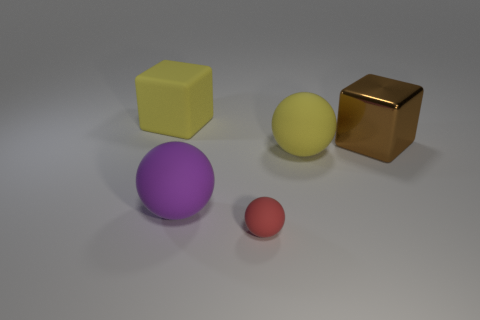Is there any other thing that has the same size as the red object?
Your answer should be compact. No. There is a large yellow thing in front of the big brown shiny block; what is it made of?
Give a very brief answer. Rubber. The red thing has what size?
Make the answer very short. Small. There is a thing behind the big shiny cube; is its size the same as the yellow matte object that is in front of the big shiny object?
Make the answer very short. Yes. There is a yellow thing that is the same shape as the small red matte thing; what size is it?
Provide a succinct answer. Large. There is a yellow block; does it have the same size as the cube that is right of the large yellow sphere?
Your answer should be very brief. Yes. There is a large yellow thing that is right of the small red rubber ball; is there a matte cube to the right of it?
Your answer should be very brief. No. What is the shape of the yellow matte object that is right of the purple rubber thing?
Keep it short and to the point. Sphere. What material is the thing that is the same color as the big rubber cube?
Offer a very short reply. Rubber. What is the color of the cube on the left side of the big sphere to the left of the tiny sphere?
Offer a terse response. Yellow. 